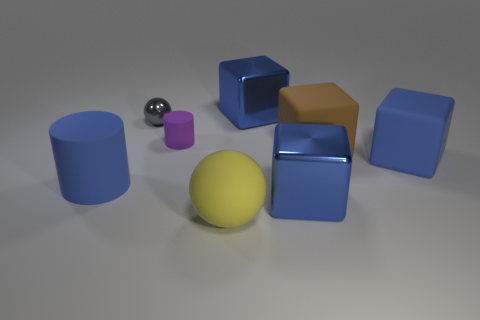What number of other objects are the same color as the big cylinder?
Your response must be concise. 3. Is the big matte ball the same color as the big rubber cylinder?
Offer a very short reply. No. There is a metallic object that is the same shape as the yellow matte object; what is its color?
Offer a very short reply. Gray. What shape is the gray metallic thing behind the big matte object that is in front of the blue cube in front of the blue matte cube?
Your response must be concise. Sphere. What size is the metallic object that is behind the large brown block and right of the gray shiny thing?
Your response must be concise. Large. Is the number of blue objects less than the number of large blue rubber cylinders?
Your response must be concise. No. There is a rubber cylinder that is on the left side of the small rubber thing; how big is it?
Ensure brevity in your answer.  Large. What shape is the big rubber object that is both behind the big yellow rubber ball and to the left of the big brown matte cube?
Ensure brevity in your answer.  Cylinder. What size is the blue matte object that is the same shape as the purple rubber thing?
Your response must be concise. Large. What number of brown cubes have the same material as the small sphere?
Ensure brevity in your answer.  0. 